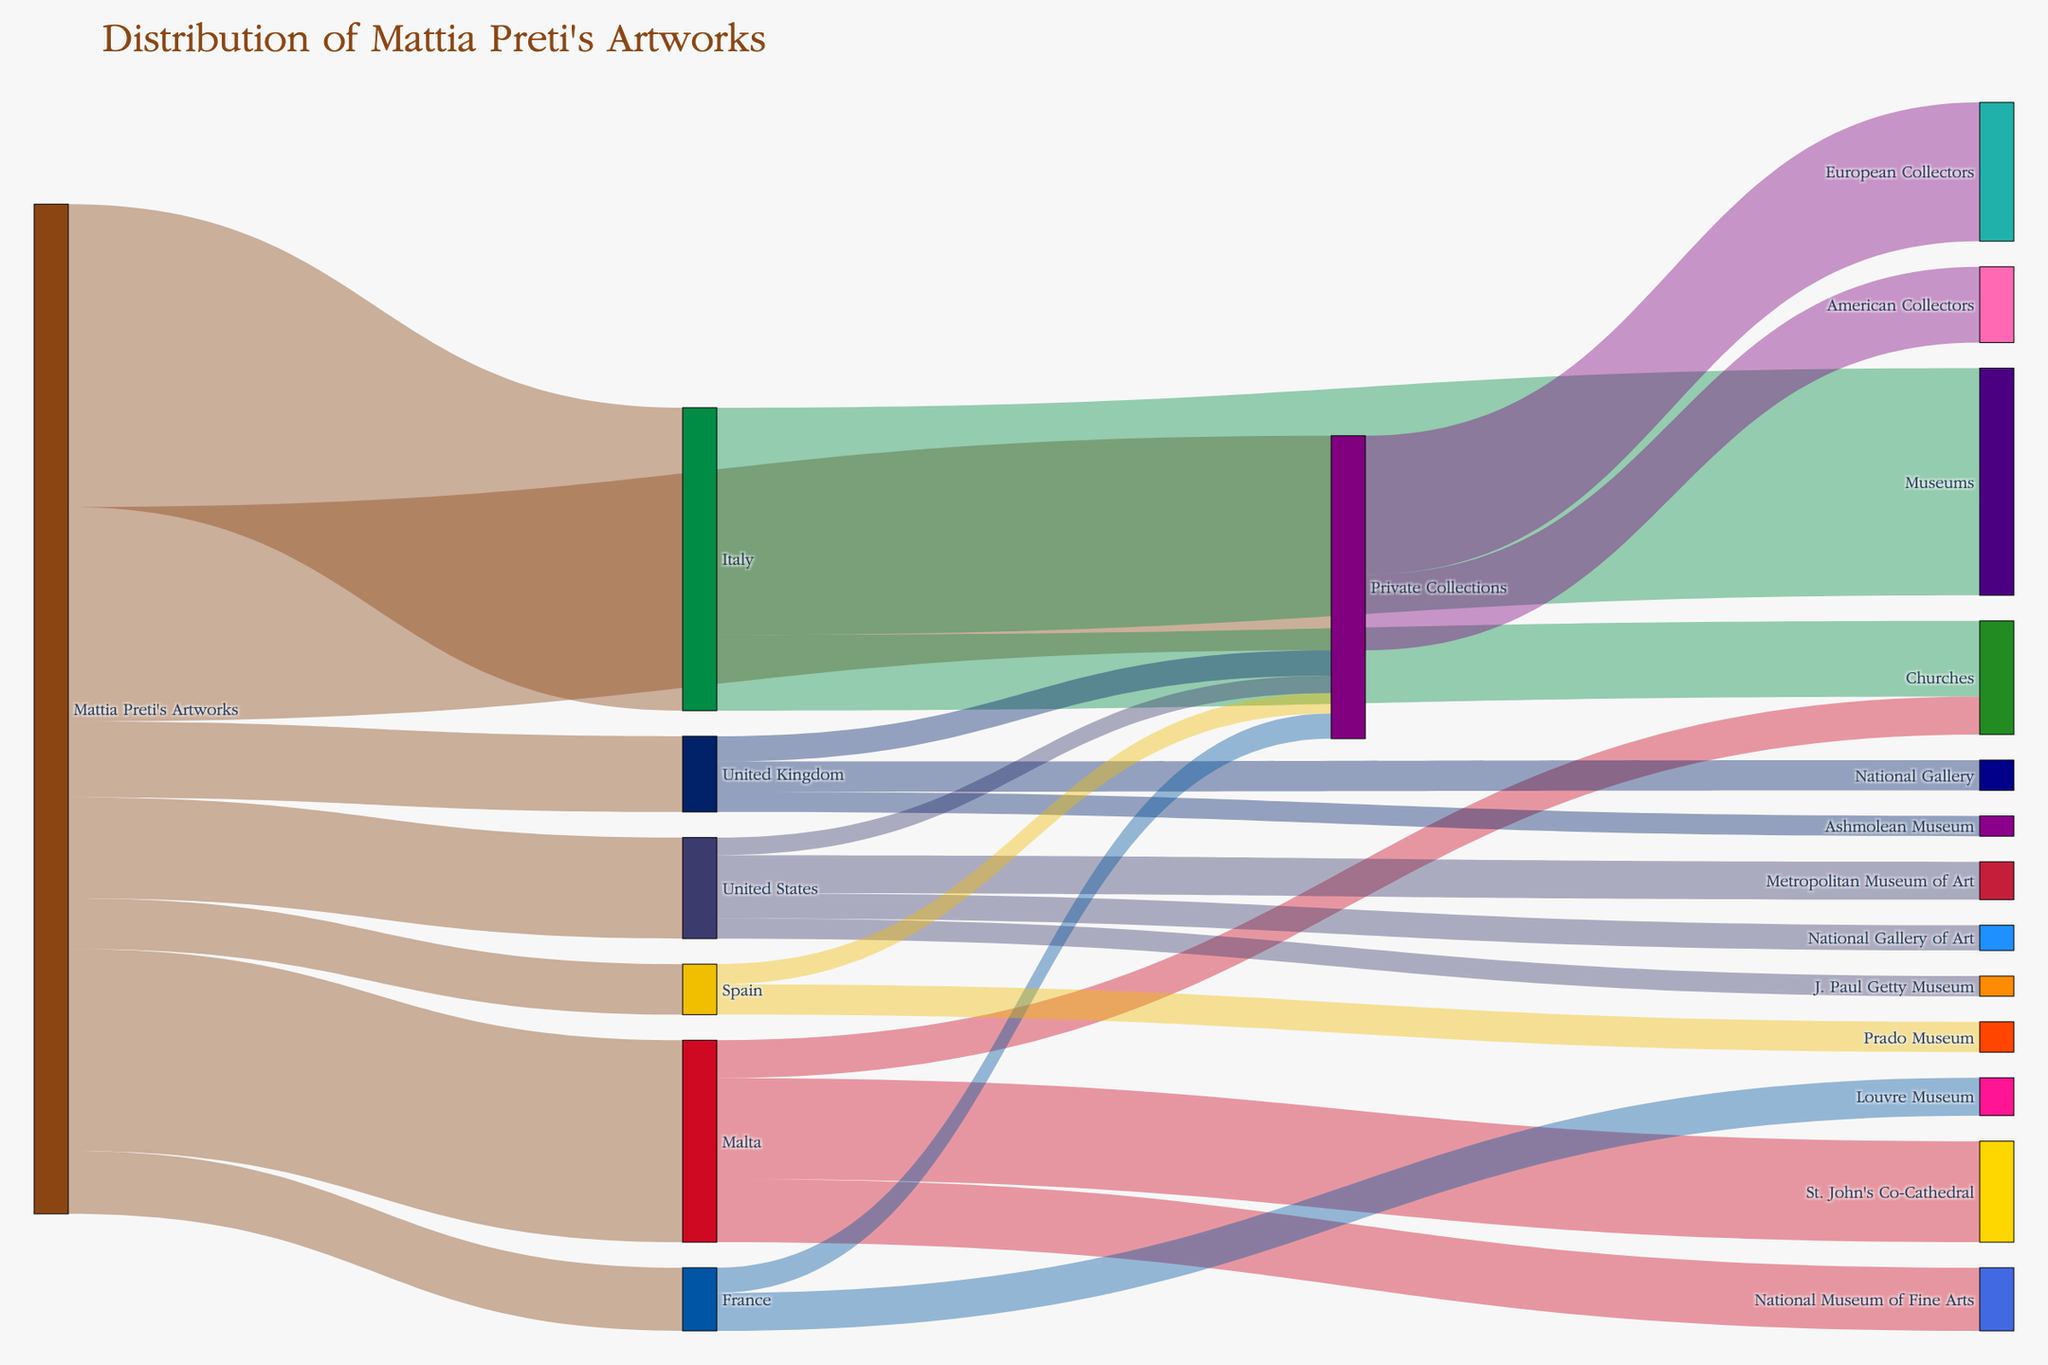how many artworks by mattia preti are located in italy? according to the figure, we can see that the link from "mattia preti's artworks" to "italy" has a value of 120.
Answer: 120 how many artworks by mattia preti are in private collections? the link from "mattia preti's artworks" to "private collections" shows a value of 85.
Answer: 85 which country has the highest number of mattia preti's artworks? by comparing the values coming out from "mattia preti's artworks" to different countries, italy has the highest number with 120.
Answer: italy how many of mattia preti's artworks in the united kingdom are in private collections? the link from "united kingdom" to "private collections" indicates a value of 10.
Answer: 10 what is the total number of artworks by mattia preti displayed in museums in the united states? we sum the values from "united states" to its museums: 15 (metropolitan museum of art) + 10 (national gallery of art) + 8 (j. paul getty museum), which gives us 33.
Answer: 33 are there more mattia preti's artworks in malta's st. john's co-cathedral or in the national museum of fine arts? comparing the values, st. john's co-cathedral has 40 while the national museum of fine arts has 25. thus, the st. john's co-cathedral has more artworks.
Answer: st. john's co-cathedral what is the total number of mattia preti's artworks spread across european collectors? the link from "private collections" to "european collectors" shows a value of 55.
Answer: 55 how many artworks by mattia preti are located in museums worldwide? we add up the values of artworks in museums across all countries: 90 (italy) + 25 (malta) + 33 (united states) + 20 (united kingdom) + 15 (france) + 12 (spain), which sums up to 195.
Answer: 195 which institution in malta holds the highest number of mattia preti's artworks? the links from "malta" to its institutions show that st. john's co-cathedral holds 40 artworks, which is the highest compared to other institutions.
Answer: st. john's co-cathedral 